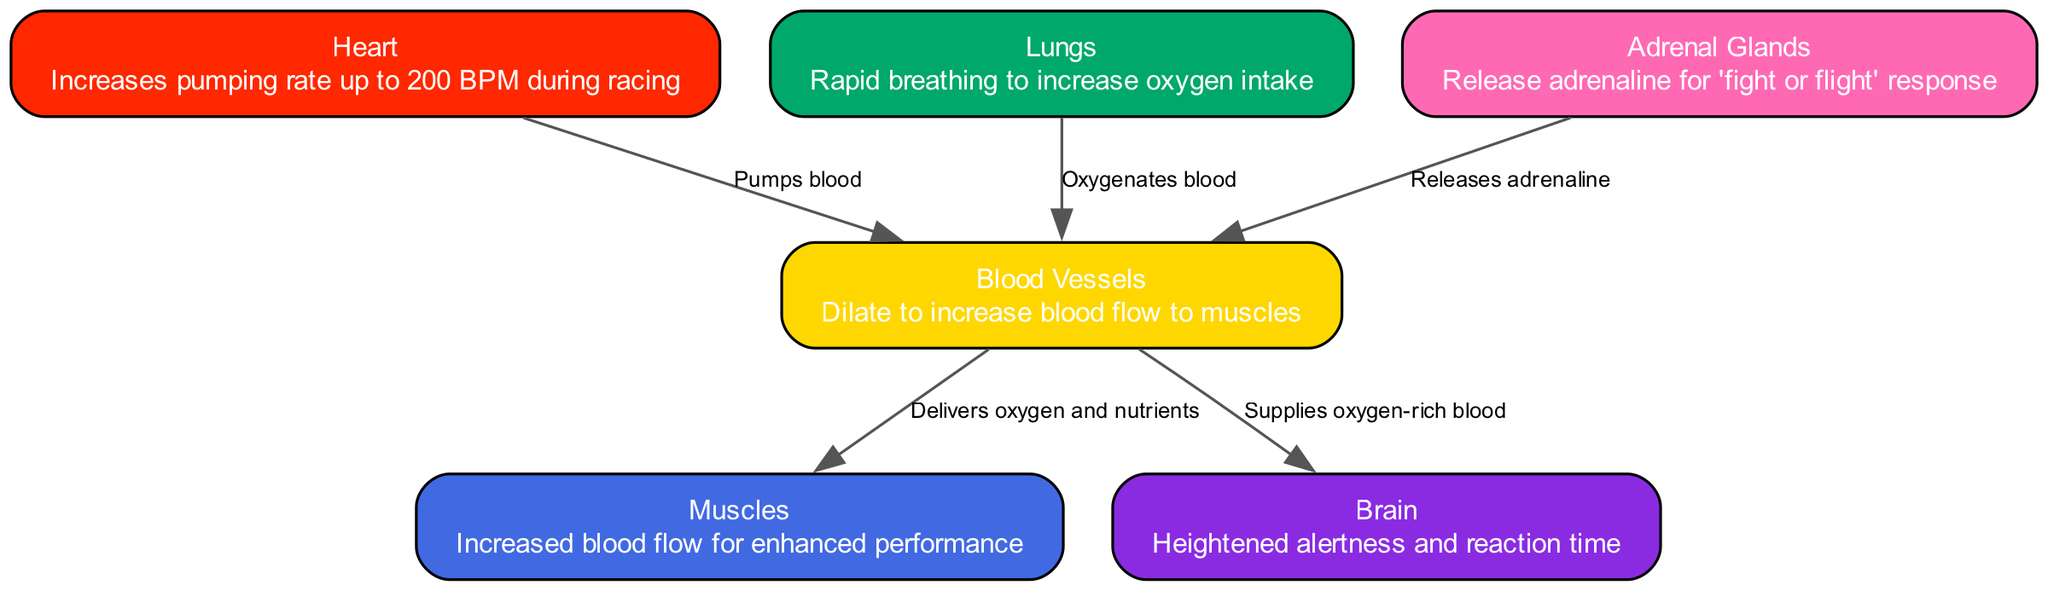What is the maximum heart rate during racing? The diagram states that the heart increases its pumping rate up to 200 BPM during racing. Therefore, the maximum heart rate mentioned is directly from the description of the heart node in the diagram.
Answer: 200 BPM How do blood vessels react during racing? According to the description in the diagram, blood vessels dilate to increase blood flow to muscles during racing, as indicated in the node description of blood vessels.
Answer: Dilate Which organ is responsible for rapid breathing? The lungs are noted in the diagram as the organ that engages in rapid breathing to increase oxygen intake, as highlighted in the nodes.
Answer: Lungs What supplies oxygen-rich blood to the brain? The edges from blood vessels to brain indicate that blood vessels are the ones that supply oxygen-rich blood to the brain, a relationship highlighted in the edges of the diagram.
Answer: Blood vessels What do adrenal glands release? The adrenal glands release adrenaline for the 'fight or flight' response, as per its description in the diagram. Hence, the direct answer is taken from the information in their node.
Answer: Adrenaline How many nodes are there in the diagram? The diagram lists a total of six nodes: heart, blood vessels, lungs, muscles, brain, and adrenal glands. To find the answer, one can simply count the nodes listed in the data provided.
Answer: 6 What effect does blood flow have on muscles? The diagram describes that increased blood flow to the muscles enhances performance, which directly relates to the nodes and the flow through blood vessels to muscles. Therefore, the answer is derived from the description of muscles.
Answer: Enhanced performance Which organ is indicated to heighten alertness? The brain is described in the diagram as having heightened alertness and reaction time. By looking at the description linked with the node for the brain, the answer can be accurately derived.
Answer: Brain What is the relationship between lungs and blood vessels? The diagram states that the lungs oxygenate blood, and this oxygenated blood is then delivered to blood vessels, indicated by the edge from lungs to blood vessels with the label "Oxygenates blood."
Answer: Oxygenates blood 